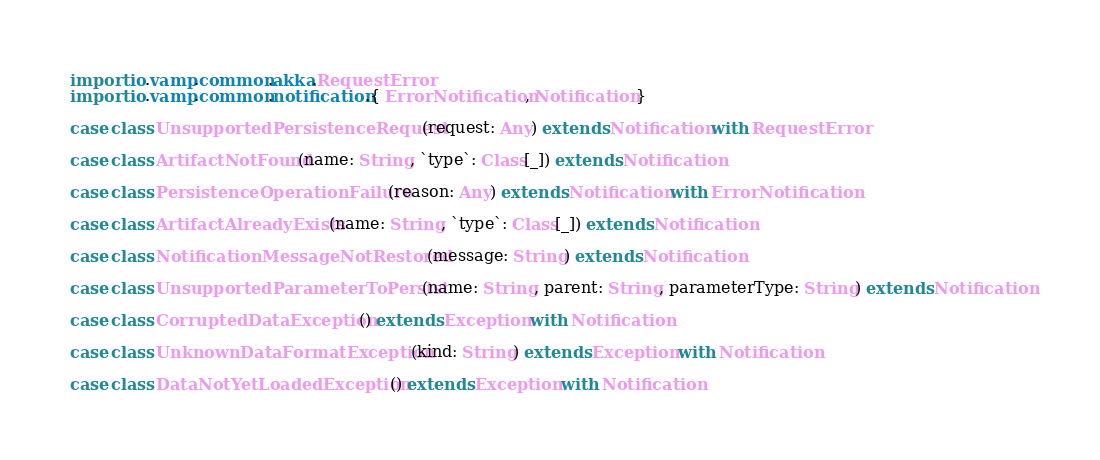<code> <loc_0><loc_0><loc_500><loc_500><_Scala_>import io.vamp.common.akka.RequestError
import io.vamp.common.notification.{ ErrorNotification, Notification }

case class UnsupportedPersistenceRequest(request: Any) extends Notification with RequestError

case class ArtifactNotFound(name: String, `type`: Class[_]) extends Notification

case class PersistenceOperationFailure(reason: Any) extends Notification with ErrorNotification

case class ArtifactAlreadyExists(name: String, `type`: Class[_]) extends Notification

case class NotificationMessageNotRestored(message: String) extends Notification

case class UnsupportedParameterToPersist(name: String, parent: String, parameterType: String) extends Notification

case class CorruptedDataException() extends Exception with Notification

case class UnknownDataFormatException(kind: String) extends Exception with Notification

case class DataNotYetLoadedException() extends Exception with Notification
</code> 